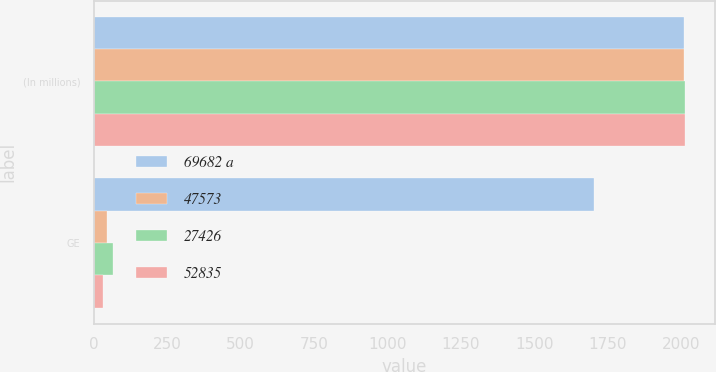Convert chart. <chart><loc_0><loc_0><loc_500><loc_500><stacked_bar_chart><ecel><fcel>(In millions)<fcel>GE<nl><fcel>69682 a<fcel>2009<fcel>1703<nl><fcel>47573<fcel>2010<fcel>44<nl><fcel>27426<fcel>2011<fcel>65<nl><fcel>52835<fcel>2012<fcel>32<nl></chart> 